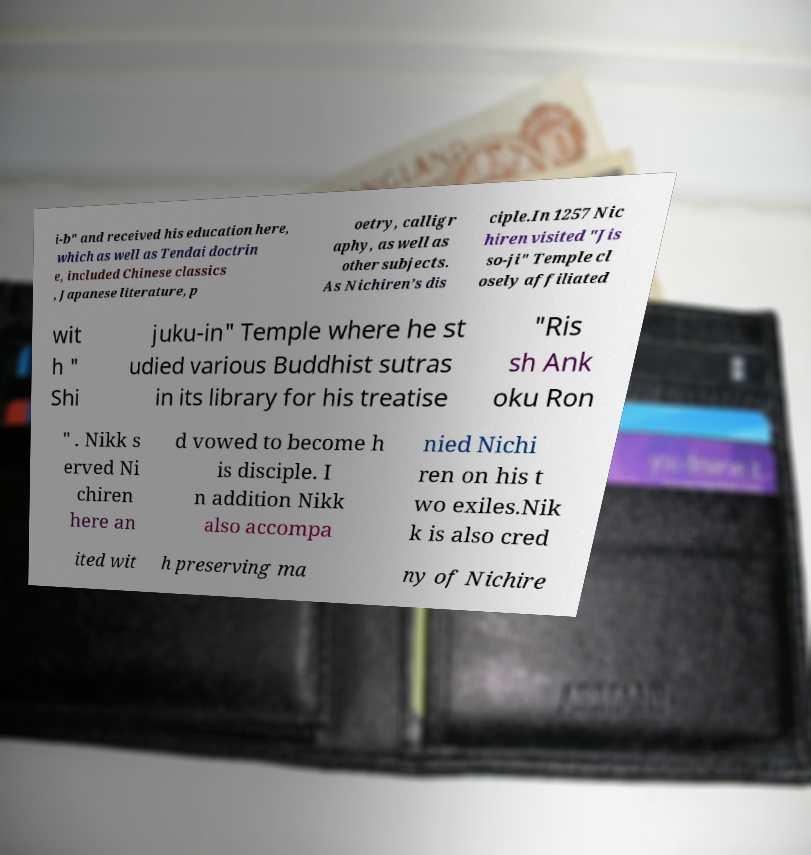For documentation purposes, I need the text within this image transcribed. Could you provide that? i-b" and received his education here, which as well as Tendai doctrin e, included Chinese classics , Japanese literature, p oetry, calligr aphy, as well as other subjects. As Nichiren’s dis ciple.In 1257 Nic hiren visited "Jis so-ji" Temple cl osely affiliated wit h " Shi juku-in" Temple where he st udied various Buddhist sutras in its library for his treatise "Ris sh Ank oku Ron " . Nikk s erved Ni chiren here an d vowed to become h is disciple. I n addition Nikk also accompa nied Nichi ren on his t wo exiles.Nik k is also cred ited wit h preserving ma ny of Nichire 